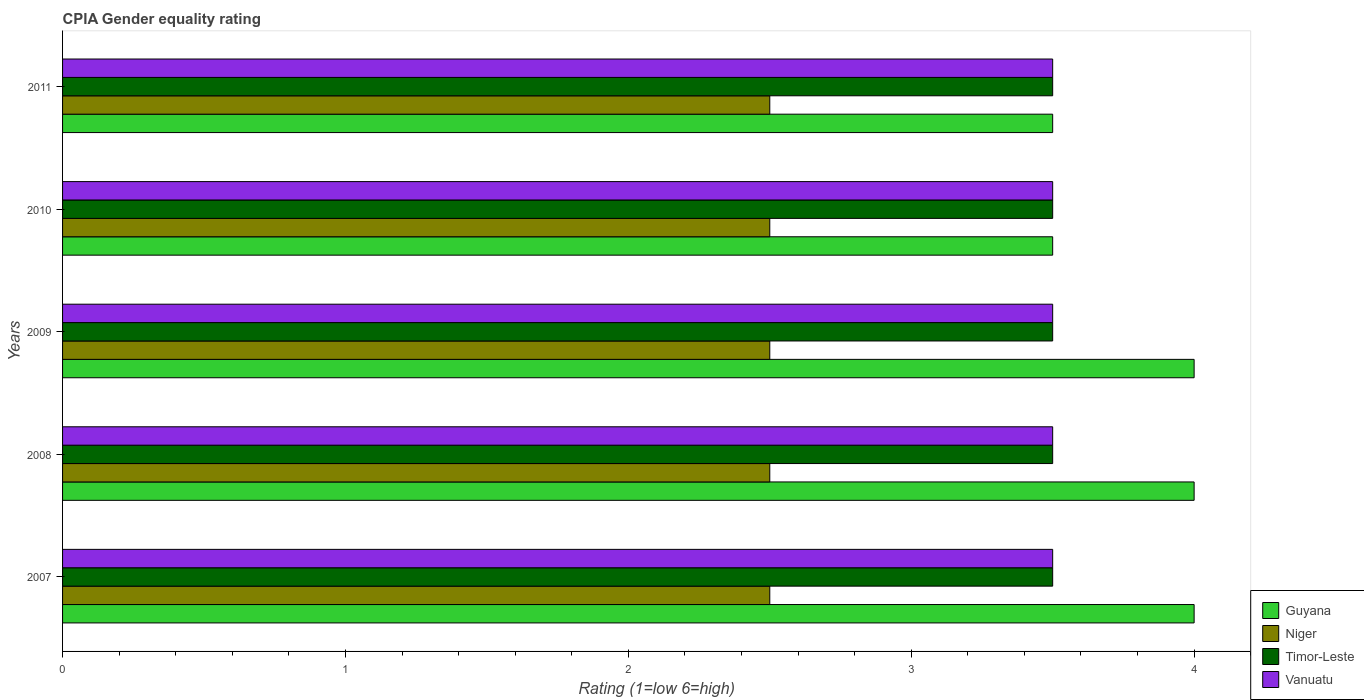How many different coloured bars are there?
Provide a succinct answer. 4. Are the number of bars on each tick of the Y-axis equal?
Give a very brief answer. Yes. How many bars are there on the 2nd tick from the top?
Your answer should be compact. 4. In how many cases, is the number of bars for a given year not equal to the number of legend labels?
Offer a terse response. 0. In which year was the CPIA rating in Timor-Leste maximum?
Offer a terse response. 2007. What is the total CPIA rating in Guyana in the graph?
Provide a short and direct response. 19. What is the difference between the CPIA rating in Niger in 2007 and that in 2008?
Your response must be concise. 0. What is the difference between the CPIA rating in Niger in 2009 and the CPIA rating in Guyana in 2011?
Ensure brevity in your answer.  -1. In the year 2011, what is the difference between the CPIA rating in Niger and CPIA rating in Vanuatu?
Provide a short and direct response. -1. In how many years, is the CPIA rating in Niger greater than 2.6 ?
Your answer should be very brief. 0. What is the ratio of the CPIA rating in Guyana in 2008 to that in 2010?
Offer a terse response. 1.14. What is the difference between the highest and the second highest CPIA rating in Timor-Leste?
Your response must be concise. 0. In how many years, is the CPIA rating in Niger greater than the average CPIA rating in Niger taken over all years?
Provide a short and direct response. 0. Is the sum of the CPIA rating in Guyana in 2009 and 2010 greater than the maximum CPIA rating in Timor-Leste across all years?
Offer a terse response. Yes. Is it the case that in every year, the sum of the CPIA rating in Vanuatu and CPIA rating in Guyana is greater than the sum of CPIA rating in Niger and CPIA rating in Timor-Leste?
Give a very brief answer. No. What does the 1st bar from the top in 2011 represents?
Your answer should be very brief. Vanuatu. What does the 4th bar from the bottom in 2009 represents?
Offer a very short reply. Vanuatu. How many bars are there?
Keep it short and to the point. 20. Are all the bars in the graph horizontal?
Make the answer very short. Yes. What is the difference between two consecutive major ticks on the X-axis?
Your response must be concise. 1. Are the values on the major ticks of X-axis written in scientific E-notation?
Ensure brevity in your answer.  No. Does the graph contain any zero values?
Ensure brevity in your answer.  No. How many legend labels are there?
Ensure brevity in your answer.  4. How are the legend labels stacked?
Your answer should be very brief. Vertical. What is the title of the graph?
Your answer should be compact. CPIA Gender equality rating. What is the label or title of the X-axis?
Keep it short and to the point. Rating (1=low 6=high). What is the label or title of the Y-axis?
Ensure brevity in your answer.  Years. What is the Rating (1=low 6=high) in Guyana in 2008?
Offer a terse response. 4. What is the Rating (1=low 6=high) in Niger in 2008?
Provide a succinct answer. 2.5. What is the Rating (1=low 6=high) of Vanuatu in 2008?
Offer a very short reply. 3.5. What is the Rating (1=low 6=high) in Niger in 2009?
Your answer should be compact. 2.5. What is the Rating (1=low 6=high) of Timor-Leste in 2009?
Your answer should be compact. 3.5. What is the Rating (1=low 6=high) of Vanuatu in 2009?
Your response must be concise. 3.5. What is the Rating (1=low 6=high) of Guyana in 2010?
Provide a short and direct response. 3.5. What is the Rating (1=low 6=high) of Vanuatu in 2010?
Give a very brief answer. 3.5. What is the Rating (1=low 6=high) of Guyana in 2011?
Offer a terse response. 3.5. What is the Rating (1=low 6=high) in Niger in 2011?
Your answer should be compact. 2.5. What is the Rating (1=low 6=high) in Timor-Leste in 2011?
Give a very brief answer. 3.5. What is the Rating (1=low 6=high) of Vanuatu in 2011?
Keep it short and to the point. 3.5. Across all years, what is the maximum Rating (1=low 6=high) in Guyana?
Your answer should be compact. 4. Across all years, what is the minimum Rating (1=low 6=high) of Guyana?
Provide a short and direct response. 3.5. What is the total Rating (1=low 6=high) in Guyana in the graph?
Provide a succinct answer. 19. What is the total Rating (1=low 6=high) in Timor-Leste in the graph?
Make the answer very short. 17.5. What is the total Rating (1=low 6=high) in Vanuatu in the graph?
Your answer should be compact. 17.5. What is the difference between the Rating (1=low 6=high) in Niger in 2007 and that in 2008?
Ensure brevity in your answer.  0. What is the difference between the Rating (1=low 6=high) of Timor-Leste in 2007 and that in 2008?
Your answer should be very brief. 0. What is the difference between the Rating (1=low 6=high) of Vanuatu in 2007 and that in 2008?
Make the answer very short. 0. What is the difference between the Rating (1=low 6=high) of Guyana in 2007 and that in 2009?
Your response must be concise. 0. What is the difference between the Rating (1=low 6=high) in Timor-Leste in 2007 and that in 2009?
Offer a very short reply. 0. What is the difference between the Rating (1=low 6=high) of Guyana in 2007 and that in 2010?
Your response must be concise. 0.5. What is the difference between the Rating (1=low 6=high) in Niger in 2007 and that in 2010?
Offer a terse response. 0. What is the difference between the Rating (1=low 6=high) in Guyana in 2007 and that in 2011?
Your answer should be compact. 0.5. What is the difference between the Rating (1=low 6=high) of Vanuatu in 2007 and that in 2011?
Offer a terse response. 0. What is the difference between the Rating (1=low 6=high) in Timor-Leste in 2008 and that in 2009?
Your response must be concise. 0. What is the difference between the Rating (1=low 6=high) of Niger in 2008 and that in 2010?
Your answer should be compact. 0. What is the difference between the Rating (1=low 6=high) of Timor-Leste in 2008 and that in 2010?
Your answer should be compact. 0. What is the difference between the Rating (1=low 6=high) in Niger in 2008 and that in 2011?
Keep it short and to the point. 0. What is the difference between the Rating (1=low 6=high) of Vanuatu in 2008 and that in 2011?
Keep it short and to the point. 0. What is the difference between the Rating (1=low 6=high) of Guyana in 2009 and that in 2010?
Offer a terse response. 0.5. What is the difference between the Rating (1=low 6=high) of Vanuatu in 2009 and that in 2010?
Give a very brief answer. 0. What is the difference between the Rating (1=low 6=high) in Timor-Leste in 2009 and that in 2011?
Your answer should be compact. 0. What is the difference between the Rating (1=low 6=high) in Vanuatu in 2009 and that in 2011?
Offer a very short reply. 0. What is the difference between the Rating (1=low 6=high) of Vanuatu in 2010 and that in 2011?
Ensure brevity in your answer.  0. What is the difference between the Rating (1=low 6=high) in Guyana in 2007 and the Rating (1=low 6=high) in Timor-Leste in 2008?
Provide a succinct answer. 0.5. What is the difference between the Rating (1=low 6=high) in Guyana in 2007 and the Rating (1=low 6=high) in Vanuatu in 2008?
Provide a succinct answer. 0.5. What is the difference between the Rating (1=low 6=high) in Niger in 2007 and the Rating (1=low 6=high) in Timor-Leste in 2008?
Your answer should be very brief. -1. What is the difference between the Rating (1=low 6=high) in Niger in 2007 and the Rating (1=low 6=high) in Vanuatu in 2008?
Provide a succinct answer. -1. What is the difference between the Rating (1=low 6=high) in Guyana in 2007 and the Rating (1=low 6=high) in Niger in 2009?
Your response must be concise. 1.5. What is the difference between the Rating (1=low 6=high) of Niger in 2007 and the Rating (1=low 6=high) of Timor-Leste in 2009?
Offer a very short reply. -1. What is the difference between the Rating (1=low 6=high) of Guyana in 2007 and the Rating (1=low 6=high) of Niger in 2010?
Give a very brief answer. 1.5. What is the difference between the Rating (1=low 6=high) in Guyana in 2007 and the Rating (1=low 6=high) in Timor-Leste in 2010?
Keep it short and to the point. 0.5. What is the difference between the Rating (1=low 6=high) of Niger in 2007 and the Rating (1=low 6=high) of Timor-Leste in 2010?
Keep it short and to the point. -1. What is the difference between the Rating (1=low 6=high) in Timor-Leste in 2007 and the Rating (1=low 6=high) in Vanuatu in 2010?
Offer a very short reply. 0. What is the difference between the Rating (1=low 6=high) of Guyana in 2007 and the Rating (1=low 6=high) of Niger in 2011?
Provide a short and direct response. 1.5. What is the difference between the Rating (1=low 6=high) in Guyana in 2007 and the Rating (1=low 6=high) in Vanuatu in 2011?
Offer a very short reply. 0.5. What is the difference between the Rating (1=low 6=high) of Guyana in 2008 and the Rating (1=low 6=high) of Timor-Leste in 2009?
Offer a terse response. 0.5. What is the difference between the Rating (1=low 6=high) in Timor-Leste in 2008 and the Rating (1=low 6=high) in Vanuatu in 2009?
Give a very brief answer. 0. What is the difference between the Rating (1=low 6=high) in Guyana in 2008 and the Rating (1=low 6=high) in Niger in 2010?
Ensure brevity in your answer.  1.5. What is the difference between the Rating (1=low 6=high) of Guyana in 2008 and the Rating (1=low 6=high) of Timor-Leste in 2010?
Your answer should be very brief. 0.5. What is the difference between the Rating (1=low 6=high) of Guyana in 2008 and the Rating (1=low 6=high) of Vanuatu in 2010?
Your answer should be very brief. 0.5. What is the difference between the Rating (1=low 6=high) in Timor-Leste in 2008 and the Rating (1=low 6=high) in Vanuatu in 2010?
Give a very brief answer. 0. What is the difference between the Rating (1=low 6=high) of Guyana in 2008 and the Rating (1=low 6=high) of Niger in 2011?
Your answer should be compact. 1.5. What is the difference between the Rating (1=low 6=high) of Guyana in 2008 and the Rating (1=low 6=high) of Timor-Leste in 2011?
Give a very brief answer. 0.5. What is the difference between the Rating (1=low 6=high) in Guyana in 2009 and the Rating (1=low 6=high) in Niger in 2010?
Make the answer very short. 1.5. What is the difference between the Rating (1=low 6=high) in Guyana in 2009 and the Rating (1=low 6=high) in Timor-Leste in 2010?
Provide a succinct answer. 0.5. What is the difference between the Rating (1=low 6=high) of Guyana in 2009 and the Rating (1=low 6=high) of Vanuatu in 2010?
Your answer should be compact. 0.5. What is the difference between the Rating (1=low 6=high) in Niger in 2009 and the Rating (1=low 6=high) in Timor-Leste in 2010?
Your response must be concise. -1. What is the difference between the Rating (1=low 6=high) of Niger in 2009 and the Rating (1=low 6=high) of Vanuatu in 2010?
Make the answer very short. -1. What is the difference between the Rating (1=low 6=high) of Timor-Leste in 2009 and the Rating (1=low 6=high) of Vanuatu in 2010?
Your response must be concise. 0. What is the difference between the Rating (1=low 6=high) of Guyana in 2009 and the Rating (1=low 6=high) of Vanuatu in 2011?
Ensure brevity in your answer.  0.5. What is the difference between the Rating (1=low 6=high) of Niger in 2009 and the Rating (1=low 6=high) of Timor-Leste in 2011?
Your answer should be very brief. -1. What is the difference between the Rating (1=low 6=high) in Timor-Leste in 2009 and the Rating (1=low 6=high) in Vanuatu in 2011?
Your answer should be compact. 0. What is the difference between the Rating (1=low 6=high) of Guyana in 2010 and the Rating (1=low 6=high) of Niger in 2011?
Keep it short and to the point. 1. What is the difference between the Rating (1=low 6=high) in Guyana in 2010 and the Rating (1=low 6=high) in Vanuatu in 2011?
Keep it short and to the point. 0. What is the difference between the Rating (1=low 6=high) of Niger in 2010 and the Rating (1=low 6=high) of Vanuatu in 2011?
Your response must be concise. -1. What is the average Rating (1=low 6=high) in Niger per year?
Offer a very short reply. 2.5. What is the average Rating (1=low 6=high) of Timor-Leste per year?
Your answer should be compact. 3.5. In the year 2007, what is the difference between the Rating (1=low 6=high) in Guyana and Rating (1=low 6=high) in Vanuatu?
Your answer should be very brief. 0.5. In the year 2007, what is the difference between the Rating (1=low 6=high) of Timor-Leste and Rating (1=low 6=high) of Vanuatu?
Your answer should be very brief. 0. In the year 2008, what is the difference between the Rating (1=low 6=high) of Guyana and Rating (1=low 6=high) of Niger?
Keep it short and to the point. 1.5. In the year 2008, what is the difference between the Rating (1=low 6=high) of Guyana and Rating (1=low 6=high) of Timor-Leste?
Offer a terse response. 0.5. In the year 2008, what is the difference between the Rating (1=low 6=high) in Niger and Rating (1=low 6=high) in Vanuatu?
Provide a succinct answer. -1. In the year 2009, what is the difference between the Rating (1=low 6=high) in Guyana and Rating (1=low 6=high) in Niger?
Your answer should be compact. 1.5. In the year 2009, what is the difference between the Rating (1=low 6=high) in Guyana and Rating (1=low 6=high) in Vanuatu?
Your response must be concise. 0.5. In the year 2009, what is the difference between the Rating (1=low 6=high) in Niger and Rating (1=low 6=high) in Timor-Leste?
Provide a short and direct response. -1. In the year 2010, what is the difference between the Rating (1=low 6=high) of Guyana and Rating (1=low 6=high) of Vanuatu?
Offer a terse response. 0. In the year 2010, what is the difference between the Rating (1=low 6=high) in Niger and Rating (1=low 6=high) in Timor-Leste?
Your answer should be very brief. -1. In the year 2010, what is the difference between the Rating (1=low 6=high) of Timor-Leste and Rating (1=low 6=high) of Vanuatu?
Provide a short and direct response. 0. In the year 2011, what is the difference between the Rating (1=low 6=high) of Guyana and Rating (1=low 6=high) of Vanuatu?
Keep it short and to the point. 0. What is the ratio of the Rating (1=low 6=high) in Guyana in 2007 to that in 2008?
Your answer should be compact. 1. What is the ratio of the Rating (1=low 6=high) in Timor-Leste in 2007 to that in 2009?
Offer a very short reply. 1. What is the ratio of the Rating (1=low 6=high) of Guyana in 2007 to that in 2010?
Make the answer very short. 1.14. What is the ratio of the Rating (1=low 6=high) in Timor-Leste in 2007 to that in 2011?
Provide a short and direct response. 1. What is the ratio of the Rating (1=low 6=high) in Guyana in 2008 to that in 2009?
Your answer should be very brief. 1. What is the ratio of the Rating (1=low 6=high) of Niger in 2008 to that in 2009?
Give a very brief answer. 1. What is the ratio of the Rating (1=low 6=high) in Timor-Leste in 2008 to that in 2009?
Your answer should be compact. 1. What is the ratio of the Rating (1=low 6=high) of Guyana in 2008 to that in 2010?
Give a very brief answer. 1.14. What is the ratio of the Rating (1=low 6=high) of Niger in 2008 to that in 2010?
Provide a short and direct response. 1. What is the ratio of the Rating (1=low 6=high) of Vanuatu in 2008 to that in 2010?
Give a very brief answer. 1. What is the ratio of the Rating (1=low 6=high) of Guyana in 2008 to that in 2011?
Ensure brevity in your answer.  1.14. What is the ratio of the Rating (1=low 6=high) of Niger in 2008 to that in 2011?
Give a very brief answer. 1. What is the ratio of the Rating (1=low 6=high) of Guyana in 2009 to that in 2010?
Your answer should be very brief. 1.14. What is the ratio of the Rating (1=low 6=high) of Niger in 2009 to that in 2010?
Your answer should be very brief. 1. What is the ratio of the Rating (1=low 6=high) of Vanuatu in 2009 to that in 2010?
Your response must be concise. 1. What is the ratio of the Rating (1=low 6=high) of Guyana in 2009 to that in 2011?
Keep it short and to the point. 1.14. What is the ratio of the Rating (1=low 6=high) in Niger in 2010 to that in 2011?
Give a very brief answer. 1. What is the ratio of the Rating (1=low 6=high) in Timor-Leste in 2010 to that in 2011?
Offer a terse response. 1. What is the difference between the highest and the second highest Rating (1=low 6=high) in Guyana?
Provide a short and direct response. 0. What is the difference between the highest and the second highest Rating (1=low 6=high) of Niger?
Keep it short and to the point. 0. What is the difference between the highest and the lowest Rating (1=low 6=high) of Guyana?
Provide a short and direct response. 0.5. What is the difference between the highest and the lowest Rating (1=low 6=high) of Timor-Leste?
Ensure brevity in your answer.  0. 